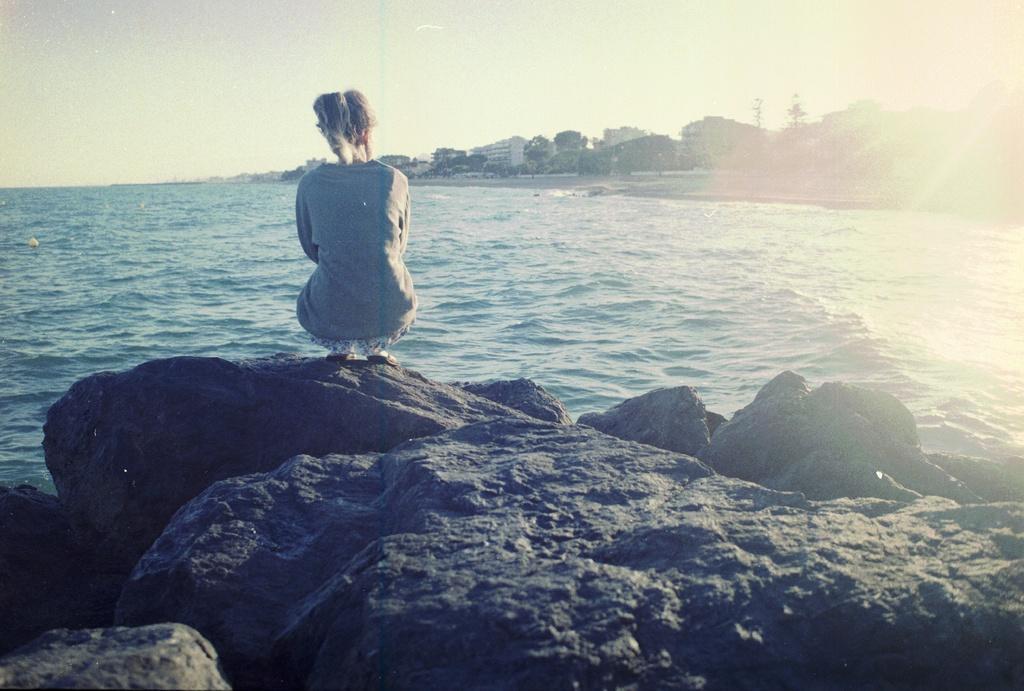Could you give a brief overview of what you see in this image? In this picture there is a woman sitting like squat position and we can see rocks and water. In the background of the image we can see buildings, trees and sky. 